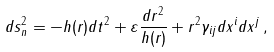Convert formula to latex. <formula><loc_0><loc_0><loc_500><loc_500>d s _ { n } ^ { 2 } = - h ( r ) d t ^ { 2 } + \varepsilon \frac { d r ^ { 2 } } { h ( r ) } + r ^ { 2 } \gamma _ { i j } d x ^ { i } d x ^ { j } \, ,</formula> 